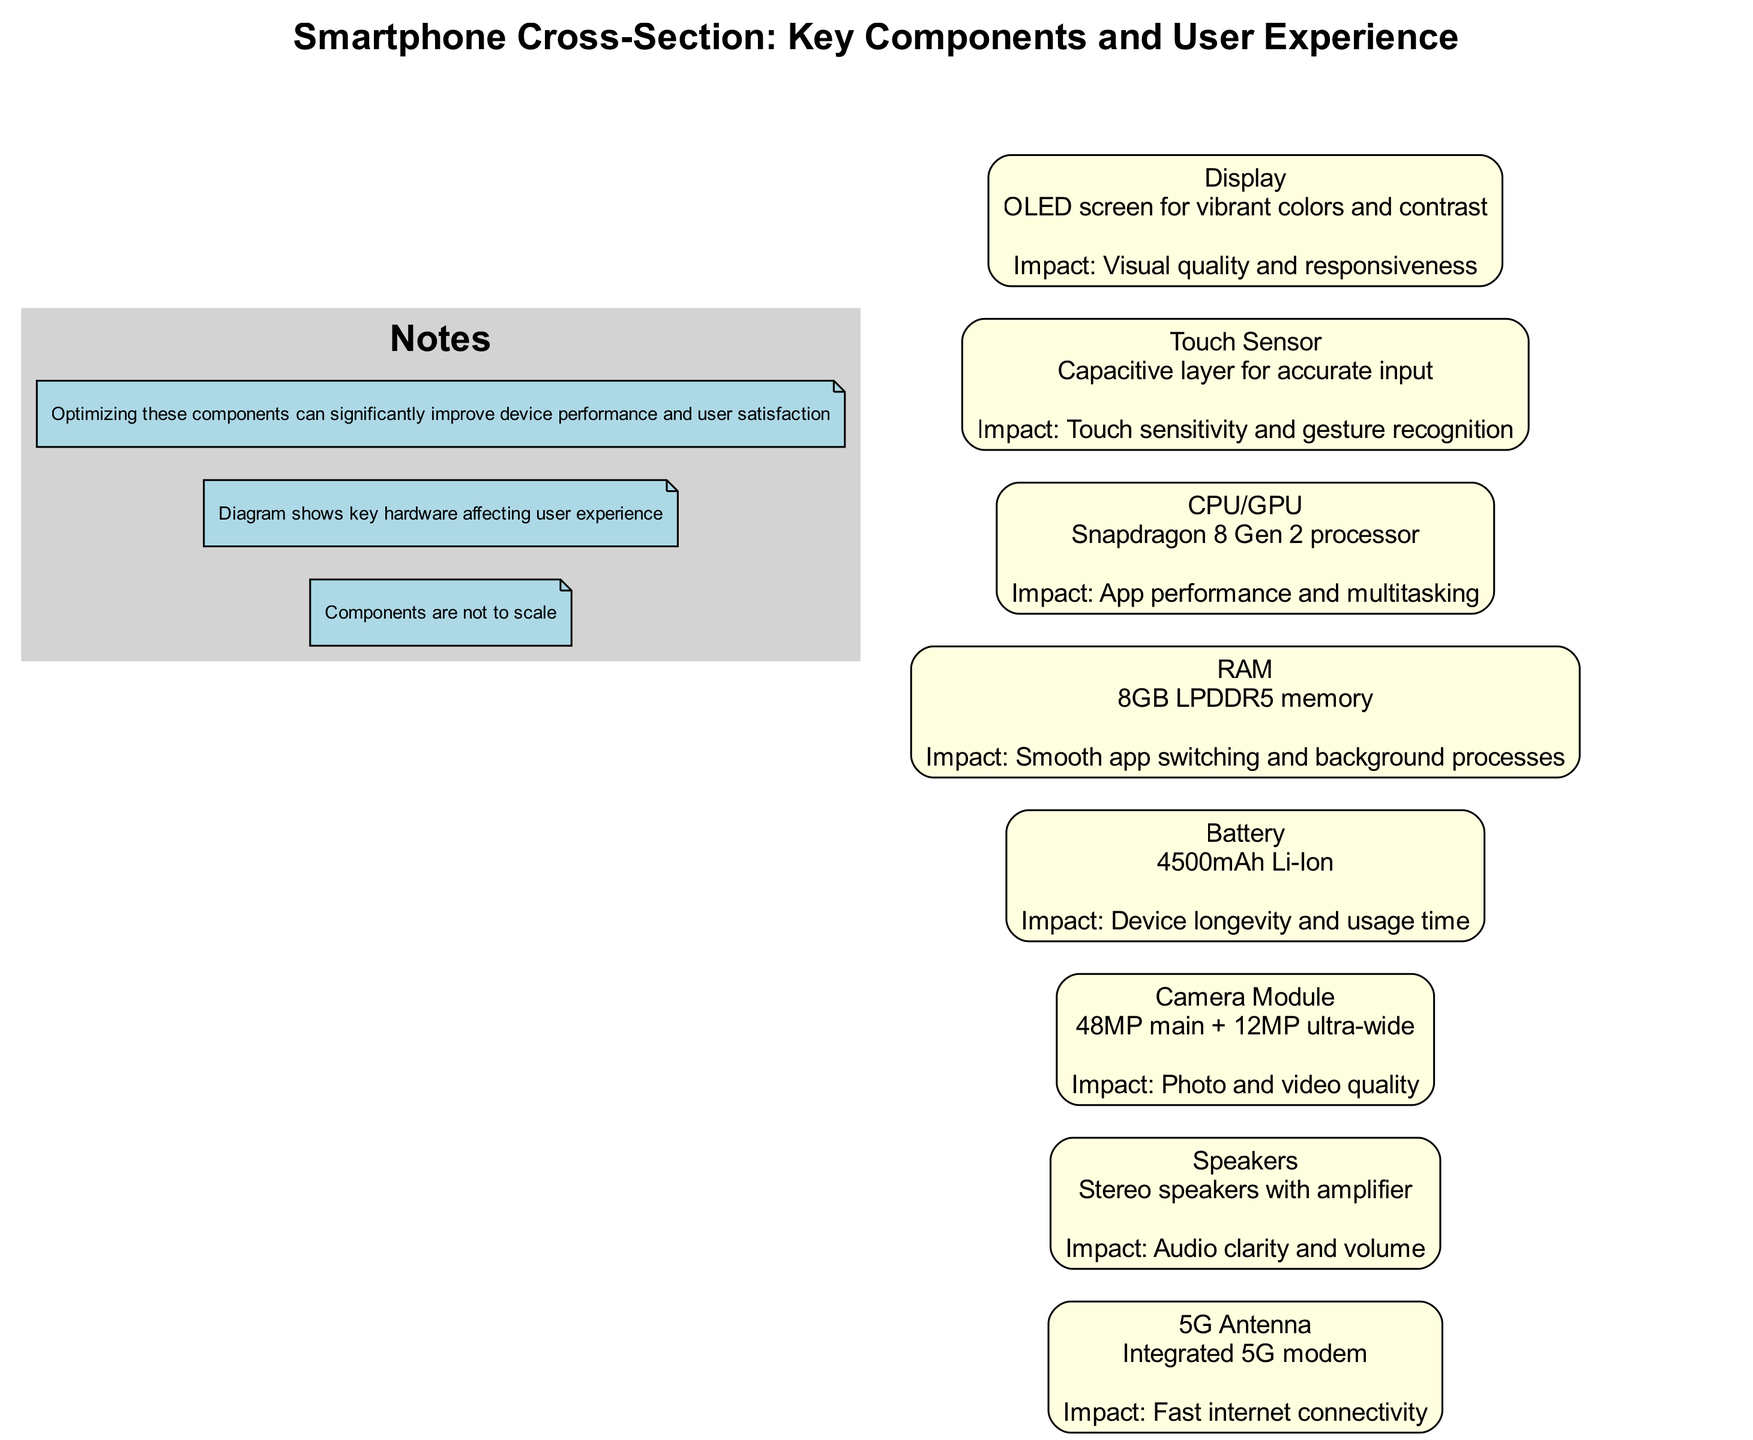What is the impact of the CPU/GPU? The impact of the CPU/GPU is stated in the diagram as app performance and multitasking. The component specifically named is the Snapdragon 8 Gen 2 processor, which is designed to enhance the overall functionality of running multiple applications smoothly.
Answer: App performance and multitasking How many components are highlighted in the diagram? The diagram lists a total of eight components, each identified with their respective details and impacts on user experience. These components include Display, Touch Sensor, CPU/GPU, RAM, Battery, Camera Module, Speakers, and 5G Antenna.
Answer: Eight What type of display is mentioned in the diagram? The diagram specifies that the display type is an OLED screen. This information is crucial as it details the display technology used in the smartphone, which signifies its visual capabilities.
Answer: OLED screen What is the battery capacity shown in the diagram? The diagram indicates that the battery capacity is 4500mAh. This detail is vital as it informs the user about the expected longevity and power usage during operation.
Answer: 4500mAh How does the Touch Sensor affect the user experience? The Touch Sensor contributes to touch sensitivity and gesture recognition, as outlined in the diagram. This impact is essential for user interaction with the device, ensuring accurate inputs based on touch.
Answer: Touch sensitivity and gesture recognition Which component is responsible for audio clarity? The component identified in the diagram responsible for audio clarity is the Speakers. It specifically notes the feature of stereo speakers with an amplifier, enhancing the sound experience during playback.
Answer: Speakers What is the impact of the RAM component in the smartphone? According to the diagram, the impact of RAM, specifically the 8GB LPDDR5 memory, is smooth app switching and background processes. This aspect highlights the importance of RAM in maintaining performance when using multiple applications.
Answer: Smooth app switching and background processes Which technology enhances internet connectivity as per the diagram? The diagram mentions the 5G Antenna as the technology that enhances internet connectivity. This is significant as it points to the device's capability to utilize faster and more reliable wireless communication.
Answer: 5G Antenna 